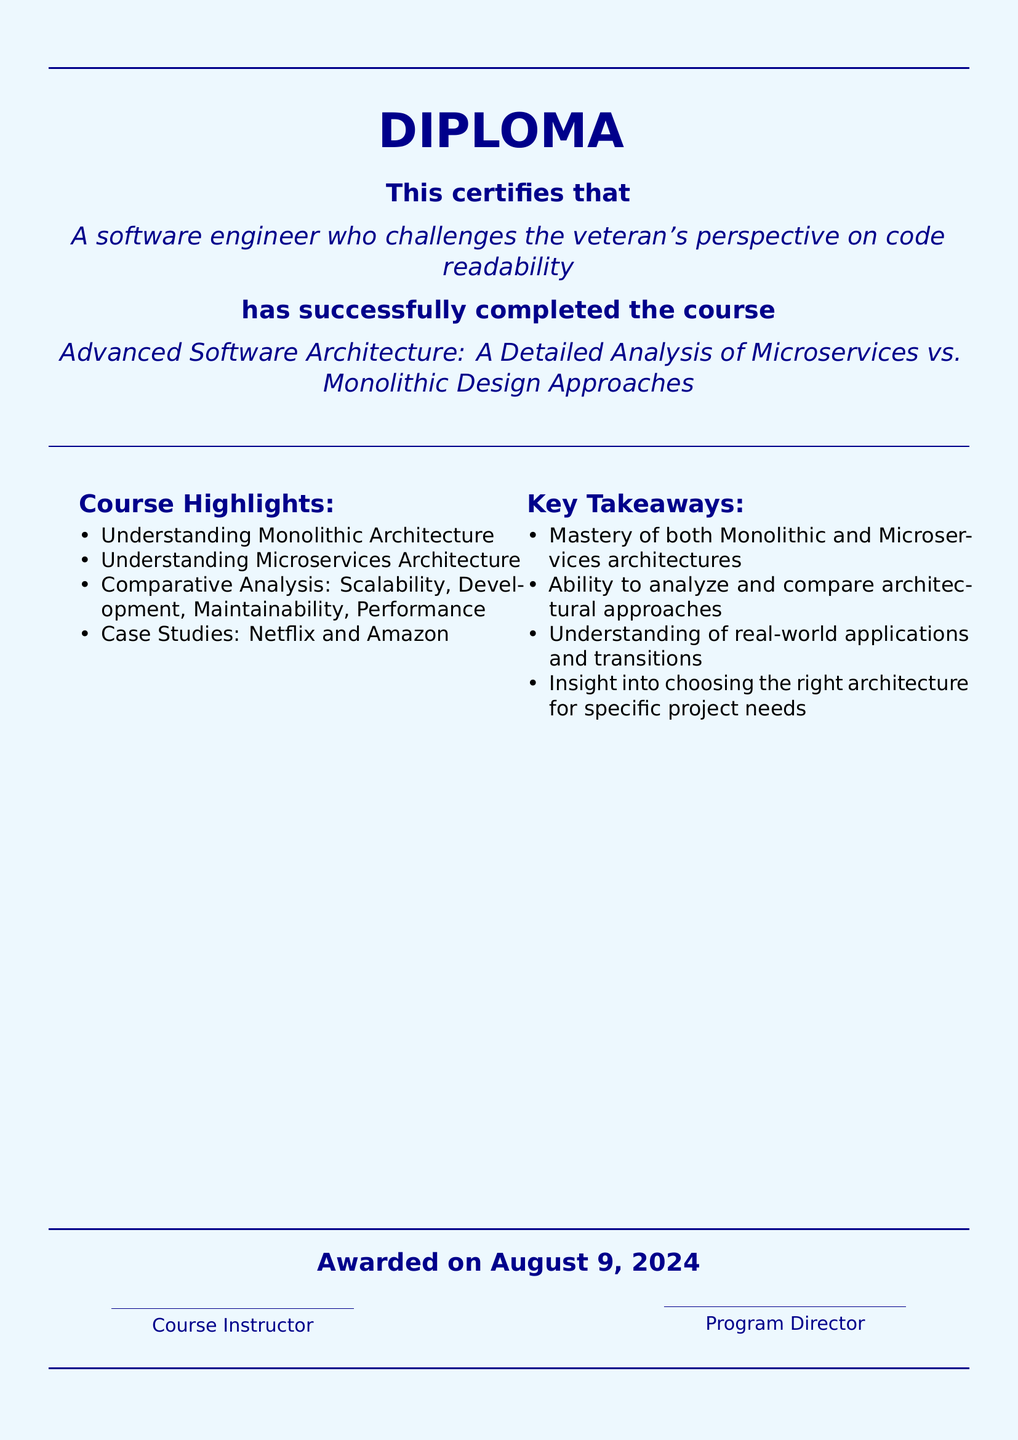What is the title of the course? The title of the course is explicitly mentioned in the document, which is "Advanced Software Architecture: A Detailed Analysis of Microservices vs. Monolithic Design Approaches."
Answer: Advanced Software Architecture: A Detailed Analysis of Microservices vs. Monolithic Design Approaches Who completed the course? The name of the individual who completed the course is presented in the document as "A software engineer who challenges the veteran's perspective on code readability."
Answer: A software engineer who challenges the veteran's perspective on code readability What are the course highlights? The document lists key highlights of the course which include multiple topics taught, such as understanding Monolithic Architecture and Microservices Architecture.
Answer: Understanding Monolithic Architecture What is one of the key takeaways? The document presents several key takeaways from the course, indicating what participants gained, such as mastery of both Monolithic and Microservices architectures.
Answer: Mastery of both Monolithic and Microservices architectures When was the diploma awarded? The document states "Awarded on" followed by the date, indicating when the diploma was issued.
Answer: Today 